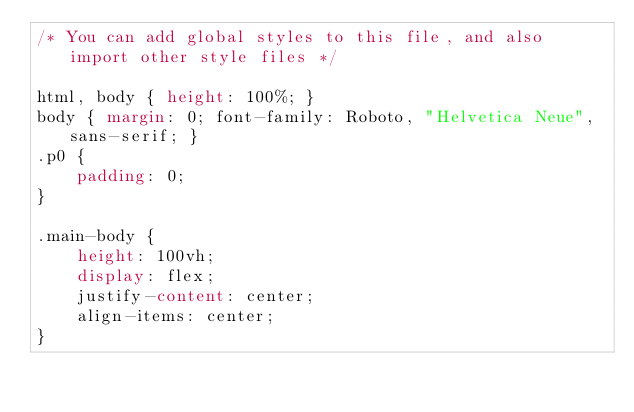Convert code to text. <code><loc_0><loc_0><loc_500><loc_500><_CSS_>/* You can add global styles to this file, and also import other style files */

html, body { height: 100%; }
body { margin: 0; font-family: Roboto, "Helvetica Neue", sans-serif; }
.p0 {
    padding: 0;
}

.main-body {
    height: 100vh;
    display: flex;
    justify-content: center;
    align-items: center;
}
</code> 